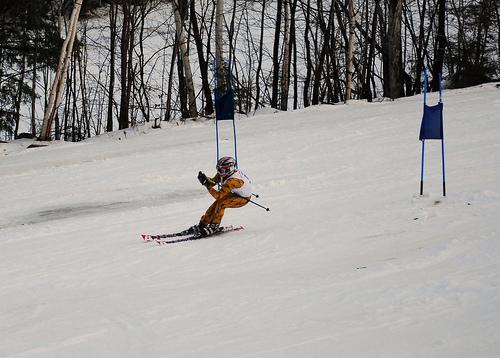Is the person in yellow a professional skier?
Quick response, please. Yes. What color are the markers?
Quick response, please. Blue. What color is the flag?
Be succinct. Blue. Is the skiing uphill?
Give a very brief answer. No. Which position is the skier in first place as of this gate?
Concise answer only. Crouched. What type of skiing is this person engaging in?
Answer briefly. Downhill. 